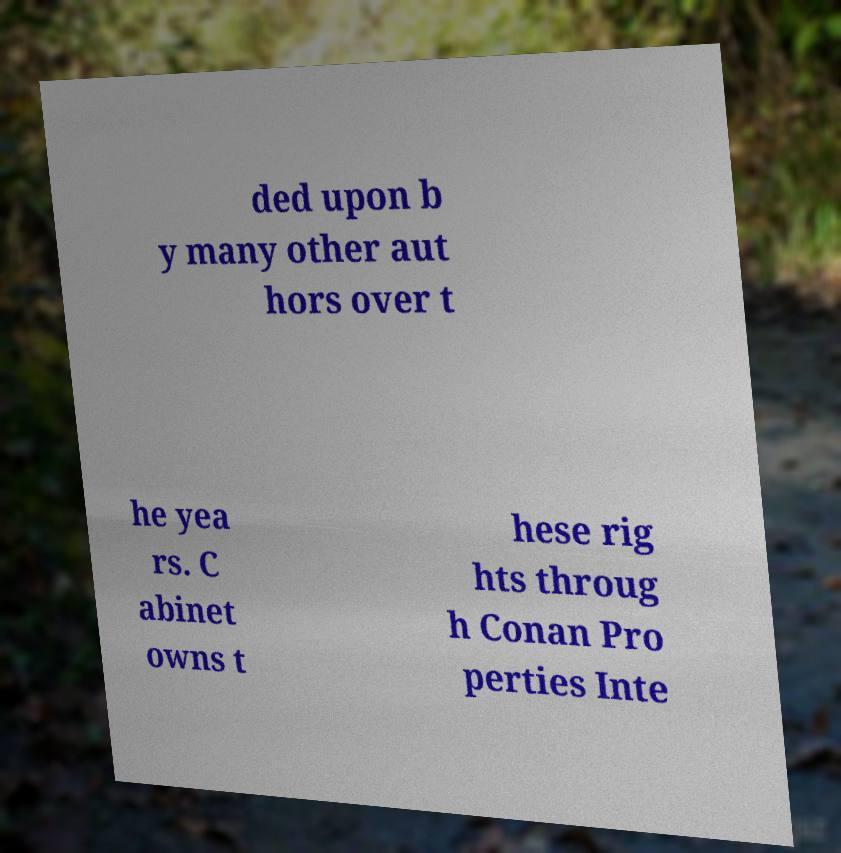I need the written content from this picture converted into text. Can you do that? ded upon b y many other aut hors over t he yea rs. C abinet owns t hese rig hts throug h Conan Pro perties Inte 